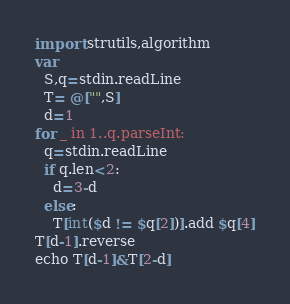<code> <loc_0><loc_0><loc_500><loc_500><_Nim_>import strutils,algorithm
var
  S,q=stdin.readLine
  T= @["",S]
  d=1
for _ in 1..q.parseInt:
  q=stdin.readLine
  if q.len<2:
    d=3-d
  else:
    T[int($d != $q[2])].add $q[4]
T[d-1].reverse
echo T[d-1]&T[2-d]</code> 